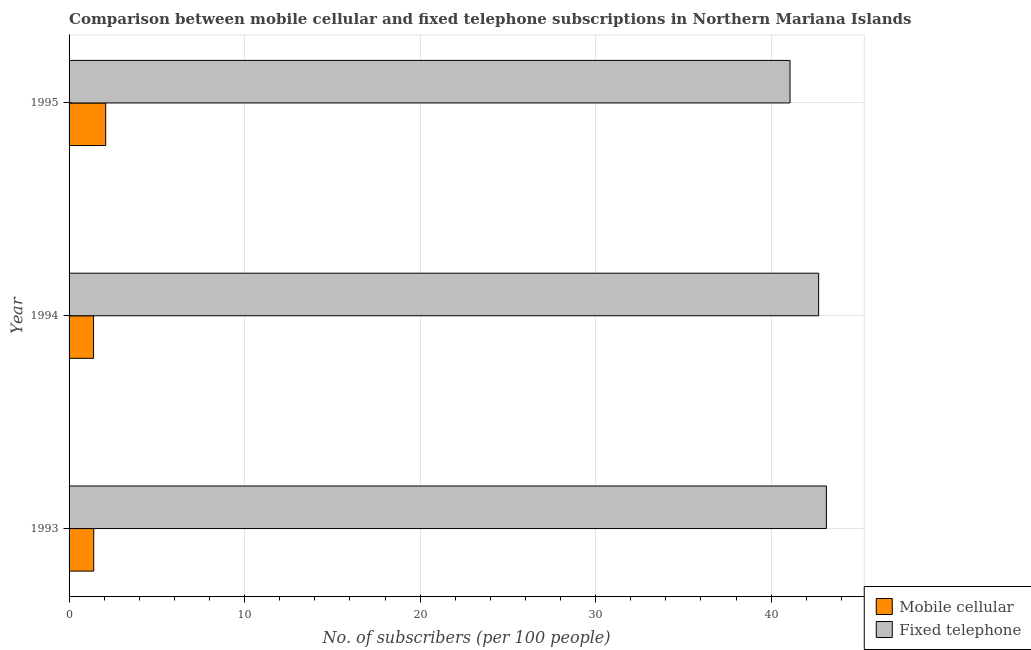How many different coloured bars are there?
Your answer should be compact. 2. How many groups of bars are there?
Your response must be concise. 3. Are the number of bars per tick equal to the number of legend labels?
Make the answer very short. Yes. How many bars are there on the 2nd tick from the top?
Offer a very short reply. 2. In how many cases, is the number of bars for a given year not equal to the number of legend labels?
Give a very brief answer. 0. What is the number of mobile cellular subscribers in 1995?
Provide a succinct answer. 2.09. Across all years, what is the maximum number of fixed telephone subscribers?
Your answer should be very brief. 43.15. Across all years, what is the minimum number of fixed telephone subscribers?
Your response must be concise. 41.08. In which year was the number of fixed telephone subscribers maximum?
Provide a succinct answer. 1993. In which year was the number of fixed telephone subscribers minimum?
Offer a very short reply. 1995. What is the total number of mobile cellular subscribers in the graph?
Your response must be concise. 4.89. What is the difference between the number of fixed telephone subscribers in 1993 and that in 1995?
Make the answer very short. 2.07. What is the difference between the number of fixed telephone subscribers in 1995 and the number of mobile cellular subscribers in 1994?
Your response must be concise. 39.68. What is the average number of fixed telephone subscribers per year?
Your answer should be compact. 42.31. In the year 1995, what is the difference between the number of fixed telephone subscribers and number of mobile cellular subscribers?
Give a very brief answer. 38.99. What is the ratio of the number of mobile cellular subscribers in 1993 to that in 1995?
Provide a short and direct response. 0.67. What is the difference between the highest and the second highest number of mobile cellular subscribers?
Your answer should be very brief. 0.68. What is the difference between the highest and the lowest number of mobile cellular subscribers?
Keep it short and to the point. 0.69. In how many years, is the number of mobile cellular subscribers greater than the average number of mobile cellular subscribers taken over all years?
Make the answer very short. 1. Is the sum of the number of fixed telephone subscribers in 1993 and 1995 greater than the maximum number of mobile cellular subscribers across all years?
Your response must be concise. Yes. What does the 2nd bar from the top in 1995 represents?
Give a very brief answer. Mobile cellular. What does the 1st bar from the bottom in 1994 represents?
Your answer should be compact. Mobile cellular. How many bars are there?
Offer a very short reply. 6. Are all the bars in the graph horizontal?
Your response must be concise. Yes. How many years are there in the graph?
Give a very brief answer. 3. What is the difference between two consecutive major ticks on the X-axis?
Ensure brevity in your answer.  10. Does the graph contain any zero values?
Your answer should be compact. No. Where does the legend appear in the graph?
Your response must be concise. Bottom right. How many legend labels are there?
Keep it short and to the point. 2. What is the title of the graph?
Provide a succinct answer. Comparison between mobile cellular and fixed telephone subscriptions in Northern Mariana Islands. Does "Merchandise imports" appear as one of the legend labels in the graph?
Keep it short and to the point. No. What is the label or title of the X-axis?
Your response must be concise. No. of subscribers (per 100 people). What is the No. of subscribers (per 100 people) of Mobile cellular in 1993?
Provide a succinct answer. 1.4. What is the No. of subscribers (per 100 people) of Fixed telephone in 1993?
Ensure brevity in your answer.  43.15. What is the No. of subscribers (per 100 people) in Mobile cellular in 1994?
Your response must be concise. 1.4. What is the No. of subscribers (per 100 people) in Fixed telephone in 1994?
Keep it short and to the point. 42.71. What is the No. of subscribers (per 100 people) in Mobile cellular in 1995?
Offer a very short reply. 2.09. What is the No. of subscribers (per 100 people) of Fixed telephone in 1995?
Provide a short and direct response. 41.08. Across all years, what is the maximum No. of subscribers (per 100 people) of Mobile cellular?
Give a very brief answer. 2.09. Across all years, what is the maximum No. of subscribers (per 100 people) in Fixed telephone?
Keep it short and to the point. 43.15. Across all years, what is the minimum No. of subscribers (per 100 people) of Mobile cellular?
Offer a terse response. 1.4. Across all years, what is the minimum No. of subscribers (per 100 people) in Fixed telephone?
Your answer should be compact. 41.08. What is the total No. of subscribers (per 100 people) of Mobile cellular in the graph?
Provide a succinct answer. 4.89. What is the total No. of subscribers (per 100 people) of Fixed telephone in the graph?
Make the answer very short. 126.93. What is the difference between the No. of subscribers (per 100 people) of Mobile cellular in 1993 and that in 1994?
Offer a very short reply. 0.01. What is the difference between the No. of subscribers (per 100 people) in Fixed telephone in 1993 and that in 1994?
Provide a short and direct response. 0.44. What is the difference between the No. of subscribers (per 100 people) in Mobile cellular in 1993 and that in 1995?
Provide a succinct answer. -0.68. What is the difference between the No. of subscribers (per 100 people) in Fixed telephone in 1993 and that in 1995?
Provide a short and direct response. 2.07. What is the difference between the No. of subscribers (per 100 people) in Mobile cellular in 1994 and that in 1995?
Provide a succinct answer. -0.69. What is the difference between the No. of subscribers (per 100 people) in Fixed telephone in 1994 and that in 1995?
Provide a short and direct response. 1.63. What is the difference between the No. of subscribers (per 100 people) of Mobile cellular in 1993 and the No. of subscribers (per 100 people) of Fixed telephone in 1994?
Your answer should be compact. -41.3. What is the difference between the No. of subscribers (per 100 people) of Mobile cellular in 1993 and the No. of subscribers (per 100 people) of Fixed telephone in 1995?
Your answer should be very brief. -39.67. What is the difference between the No. of subscribers (per 100 people) of Mobile cellular in 1994 and the No. of subscribers (per 100 people) of Fixed telephone in 1995?
Give a very brief answer. -39.68. What is the average No. of subscribers (per 100 people) of Mobile cellular per year?
Make the answer very short. 1.63. What is the average No. of subscribers (per 100 people) of Fixed telephone per year?
Provide a short and direct response. 42.31. In the year 1993, what is the difference between the No. of subscribers (per 100 people) of Mobile cellular and No. of subscribers (per 100 people) of Fixed telephone?
Give a very brief answer. -41.74. In the year 1994, what is the difference between the No. of subscribers (per 100 people) in Mobile cellular and No. of subscribers (per 100 people) in Fixed telephone?
Your answer should be compact. -41.31. In the year 1995, what is the difference between the No. of subscribers (per 100 people) in Mobile cellular and No. of subscribers (per 100 people) in Fixed telephone?
Give a very brief answer. -38.99. What is the ratio of the No. of subscribers (per 100 people) of Mobile cellular in 1993 to that in 1994?
Make the answer very short. 1.01. What is the ratio of the No. of subscribers (per 100 people) of Fixed telephone in 1993 to that in 1994?
Offer a very short reply. 1.01. What is the ratio of the No. of subscribers (per 100 people) in Mobile cellular in 1993 to that in 1995?
Your answer should be very brief. 0.67. What is the ratio of the No. of subscribers (per 100 people) of Fixed telephone in 1993 to that in 1995?
Give a very brief answer. 1.05. What is the ratio of the No. of subscribers (per 100 people) of Mobile cellular in 1994 to that in 1995?
Your answer should be compact. 0.67. What is the ratio of the No. of subscribers (per 100 people) in Fixed telephone in 1994 to that in 1995?
Your answer should be compact. 1.04. What is the difference between the highest and the second highest No. of subscribers (per 100 people) of Mobile cellular?
Your response must be concise. 0.68. What is the difference between the highest and the second highest No. of subscribers (per 100 people) in Fixed telephone?
Offer a very short reply. 0.44. What is the difference between the highest and the lowest No. of subscribers (per 100 people) in Mobile cellular?
Ensure brevity in your answer.  0.69. What is the difference between the highest and the lowest No. of subscribers (per 100 people) in Fixed telephone?
Your answer should be compact. 2.07. 